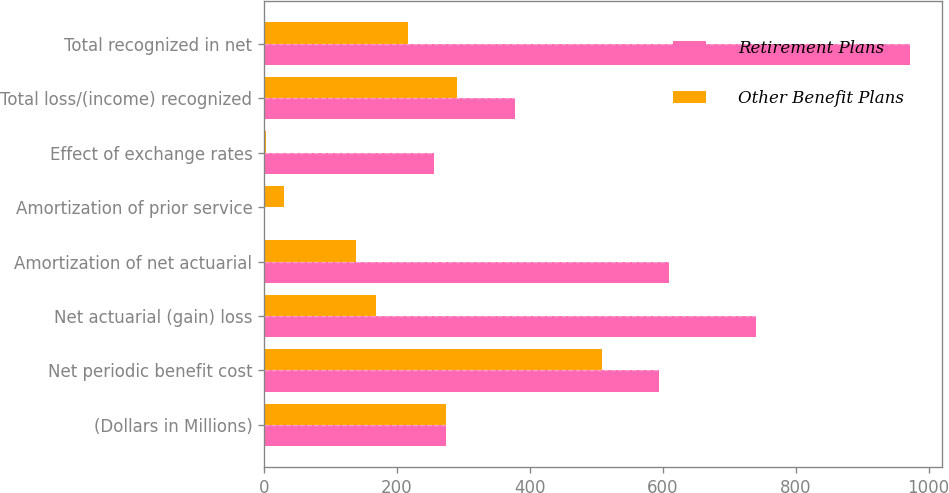Convert chart. <chart><loc_0><loc_0><loc_500><loc_500><stacked_bar_chart><ecel><fcel>(Dollars in Millions)<fcel>Net periodic benefit cost<fcel>Net actuarial (gain) loss<fcel>Amortization of net actuarial<fcel>Amortization of prior service<fcel>Effect of exchange rates<fcel>Total loss/(income) recognized<fcel>Total recognized in net<nl><fcel>Retirement Plans<fcel>273.5<fcel>594<fcel>740<fcel>609<fcel>2<fcel>256<fcel>378<fcel>972<nl><fcel>Other Benefit Plans<fcel>273.5<fcel>508<fcel>169<fcel>138<fcel>30<fcel>3<fcel>291<fcel>217<nl></chart> 